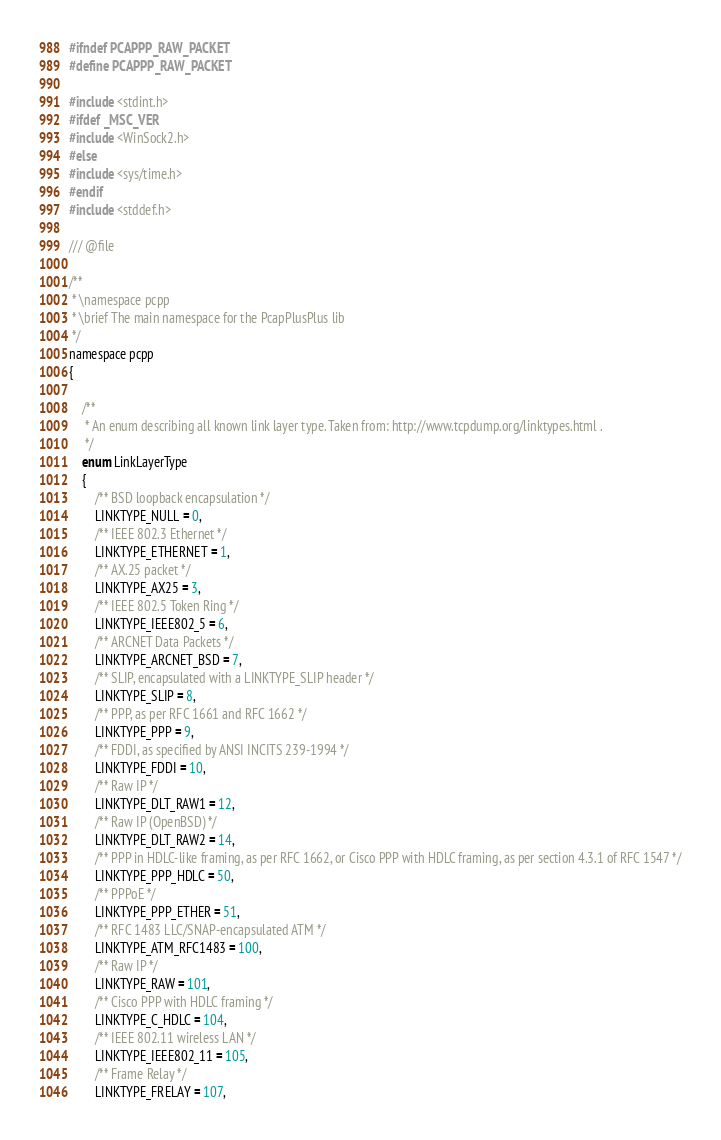<code> <loc_0><loc_0><loc_500><loc_500><_C_>#ifndef PCAPPP_RAW_PACKET
#define PCAPPP_RAW_PACKET

#include <stdint.h>
#ifdef _MSC_VER
#include <WinSock2.h>
#else
#include <sys/time.h>
#endif
#include <stddef.h>

/// @file

/**
 * \namespace pcpp
 * \brief The main namespace for the PcapPlusPlus lib
 */
namespace pcpp
{

	/**
	 * An enum describing all known link layer type. Taken from: http://www.tcpdump.org/linktypes.html .
	 */
	enum LinkLayerType
	{
		/** BSD loopback encapsulation */
		LINKTYPE_NULL = 0,
		/** IEEE 802.3 Ethernet */
		LINKTYPE_ETHERNET = 1,
		/** AX.25 packet */
		LINKTYPE_AX25 = 3,
		/** IEEE 802.5 Token Ring */
		LINKTYPE_IEEE802_5 = 6,
		/** ARCNET Data Packets */
		LINKTYPE_ARCNET_BSD = 7,
		/** SLIP, encapsulated with a LINKTYPE_SLIP header */
		LINKTYPE_SLIP = 8,
		/** PPP, as per RFC 1661 and RFC 1662 */
		LINKTYPE_PPP = 9,
		/** FDDI, as specified by ANSI INCITS 239-1994 */
		LINKTYPE_FDDI = 10,
		/** Raw IP */
		LINKTYPE_DLT_RAW1 = 12,
		/** Raw IP (OpenBSD) */
		LINKTYPE_DLT_RAW2 = 14,
		/** PPP in HDLC-like framing, as per RFC 1662, or Cisco PPP with HDLC framing, as per section 4.3.1 of RFC 1547 */
		LINKTYPE_PPP_HDLC = 50,
		/** PPPoE */
		LINKTYPE_PPP_ETHER = 51,
		/** RFC 1483 LLC/SNAP-encapsulated ATM */
		LINKTYPE_ATM_RFC1483 = 100,
		/** Raw IP */
		LINKTYPE_RAW = 101,
		/** Cisco PPP with HDLC framing */
		LINKTYPE_C_HDLC = 104,
		/** IEEE 802.11 wireless LAN */
		LINKTYPE_IEEE802_11 = 105,
		/** Frame Relay */
		LINKTYPE_FRELAY = 107,</code> 